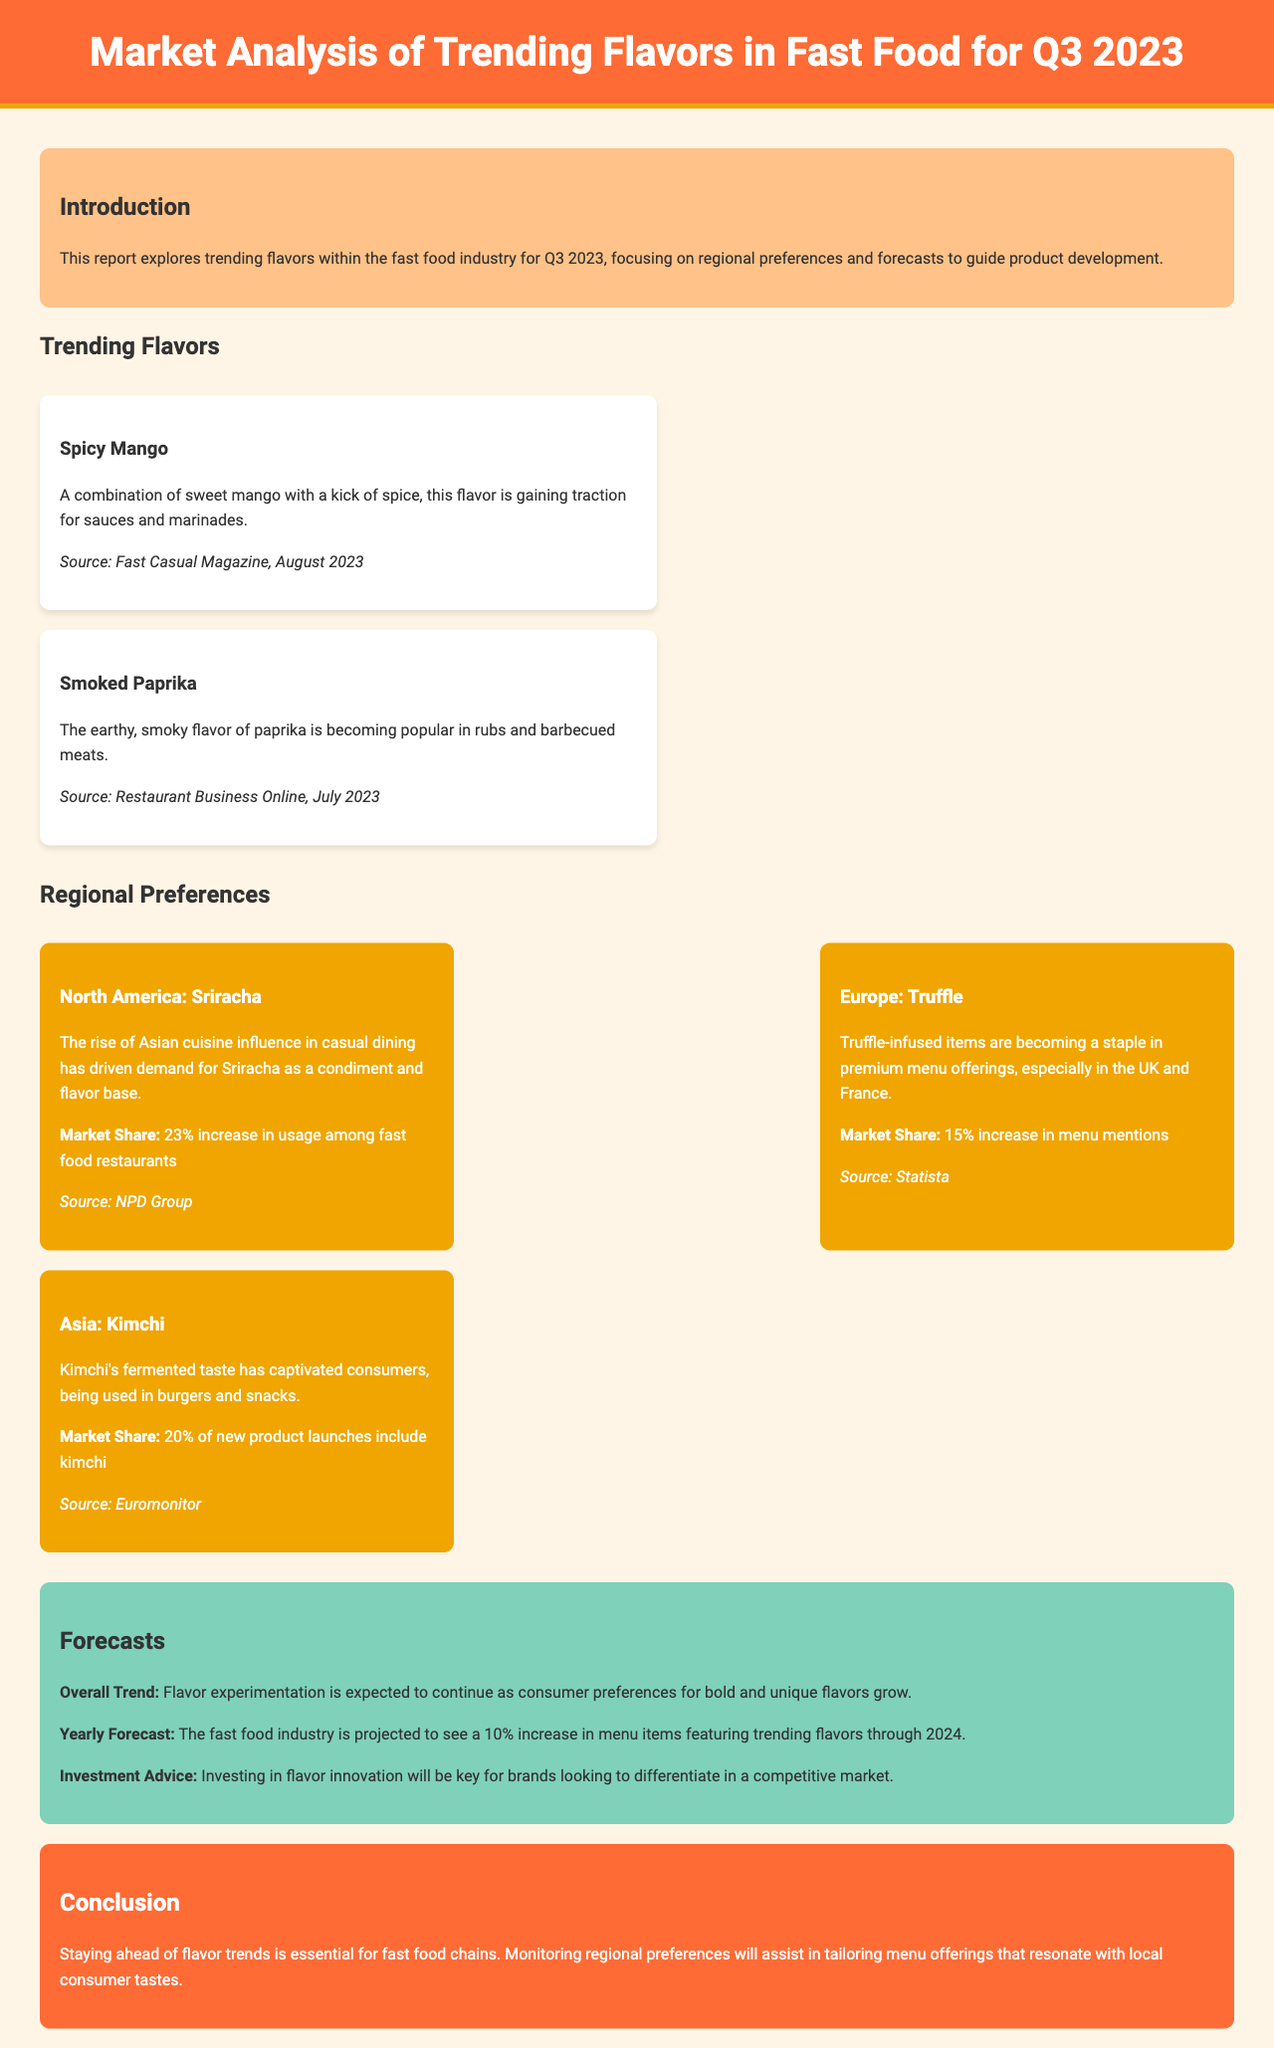What are the trending flavors mentioned in the report? The document lists two trending flavors, Spicy Mango and Smoked Paprika, as notable for Q3 2023.
Answer: Spicy Mango, Smoked Paprika What market share increase is noted for Sriracha in North America? The report states that there is a 23% increase in usage of Sriracha among fast food restaurants in North America.
Answer: 23% Which flavor is becoming popular in Europe according to the report? The document highlights Truffle as a popular flavor in Europe, specifically in the UK and France.
Answer: Truffle What is the overall trend forecasted for the fast food industry? The overall trend indicates that flavor experimentation is expected to continue with growing consumer preferences for bold and unique flavors.
Answer: Flavor experimentation What is the projected increase in menu items featuring trending flavors through 2024? The report projects a 10% increase in menu items featuring trending flavors through 2024 in the fast food industry.
Answer: 10% What is the primary advice given for investment in the report? The document advises that investing in flavor innovation will be key for brands looking to differentiate in a competitive market.
Answer: Flavor innovation 